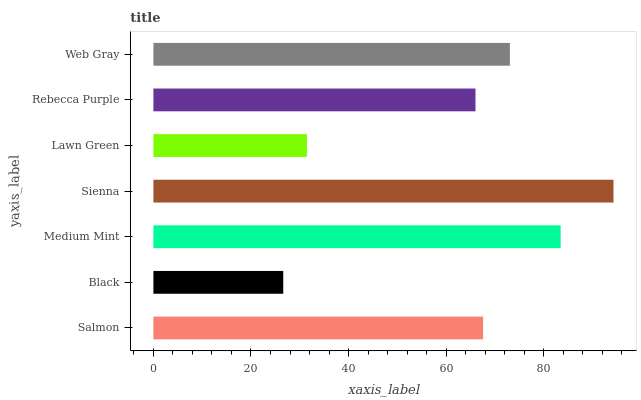Is Black the minimum?
Answer yes or no. Yes. Is Sienna the maximum?
Answer yes or no. Yes. Is Medium Mint the minimum?
Answer yes or no. No. Is Medium Mint the maximum?
Answer yes or no. No. Is Medium Mint greater than Black?
Answer yes or no. Yes. Is Black less than Medium Mint?
Answer yes or no. Yes. Is Black greater than Medium Mint?
Answer yes or no. No. Is Medium Mint less than Black?
Answer yes or no. No. Is Salmon the high median?
Answer yes or no. Yes. Is Salmon the low median?
Answer yes or no. Yes. Is Black the high median?
Answer yes or no. No. Is Lawn Green the low median?
Answer yes or no. No. 